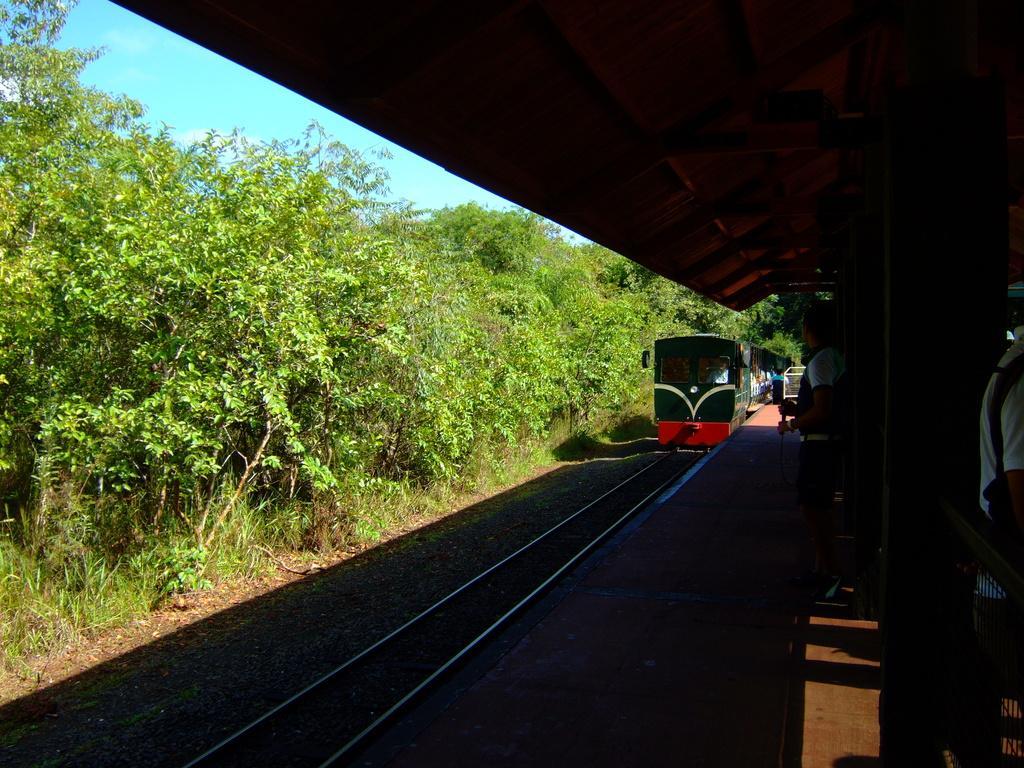Please provide a concise description of this image. In the image we can see a train on the train track. This is a grass, trees and pale blue sky. We can see there are even people wearing clothes. 